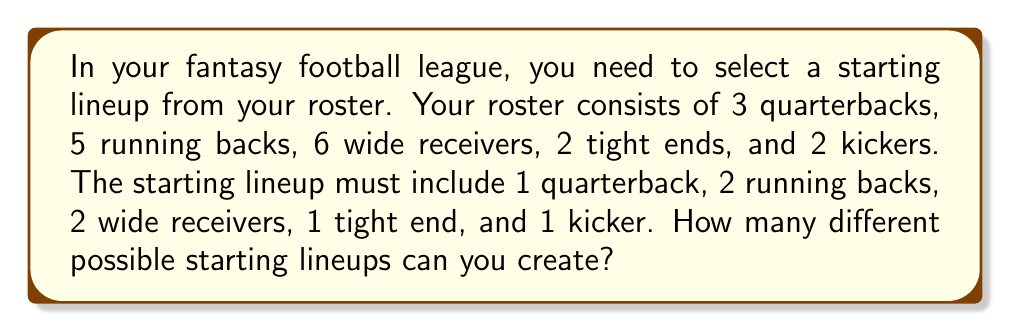Show me your answer to this math problem. To solve this problem, we'll use the multiplication principle of counting. We'll determine the number of choices for each position and then multiply them together:

1. Quarterback: We have 3 quarterbacks to choose from, and we need to select 1.
   $\binom{3}{1} = 3$ choices

2. Running backs: We have 5 running backs to choose from, and we need to select 2.
   $\binom{5}{2} = 10$ choices

3. Wide receivers: We have 6 wide receivers to choose from, and we need to select 2.
   $\binom{6}{2} = 15$ choices

4. Tight end: We have 2 tight ends to choose from, and we need to select 1.
   $\binom{2}{1} = 2$ choices

5. Kicker: We have 2 kickers to choose from, and we need to select 1.
   $\binom{2}{1} = 2$ choices

Now, we multiply these numbers together to get the total number of possible lineups:

$$3 \times 10 \times 15 \times 2 \times 2 = 1,800$$

Therefore, there are 1,800 different possible starting lineups that can be created from the given roster.
Answer: 1,800 possible starting lineups 